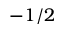<formula> <loc_0><loc_0><loc_500><loc_500>- 1 / 2</formula> 